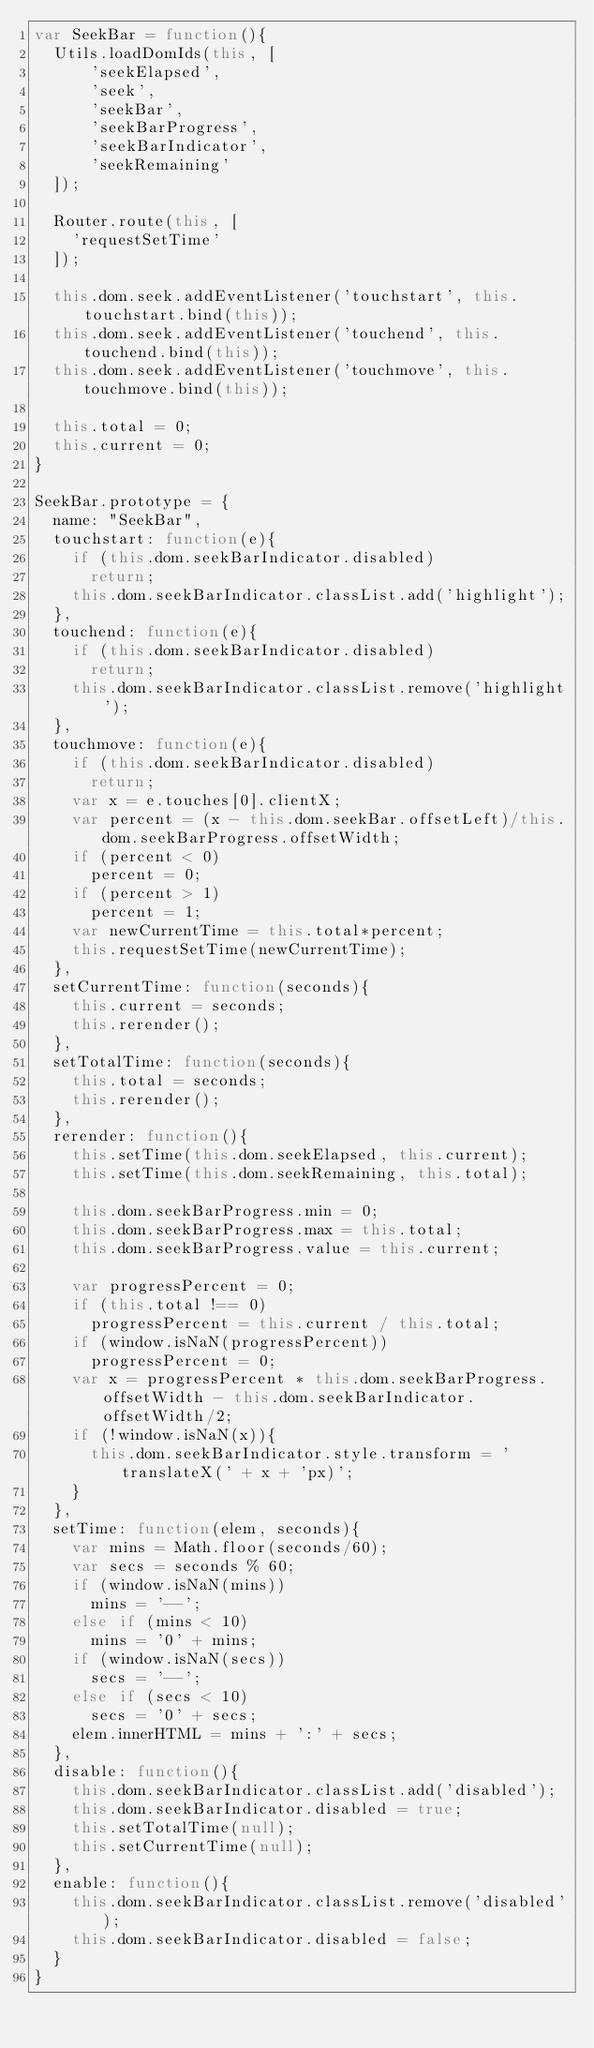<code> <loc_0><loc_0><loc_500><loc_500><_JavaScript_>var SeekBar = function(){
  Utils.loadDomIds(this, [
      'seekElapsed',
      'seek',
      'seekBar',
      'seekBarProgress',
      'seekBarIndicator',
      'seekRemaining'
  ]);

  Router.route(this, [
    'requestSetTime'
  ]);

  this.dom.seek.addEventListener('touchstart', this.touchstart.bind(this));
  this.dom.seek.addEventListener('touchend', this.touchend.bind(this));
  this.dom.seek.addEventListener('touchmove', this.touchmove.bind(this));

  this.total = 0;
  this.current = 0;
}

SeekBar.prototype = {
  name: "SeekBar",
  touchstart: function(e){
    if (this.dom.seekBarIndicator.disabled)
      return;
    this.dom.seekBarIndicator.classList.add('highlight');
  },
  touchend: function(e){
    if (this.dom.seekBarIndicator.disabled)
      return;
    this.dom.seekBarIndicator.classList.remove('highlight');
  },
  touchmove: function(e){
    if (this.dom.seekBarIndicator.disabled)
      return;
    var x = e.touches[0].clientX;
    var percent = (x - this.dom.seekBar.offsetLeft)/this.dom.seekBarProgress.offsetWidth;
    if (percent < 0)
      percent = 0;
    if (percent > 1)
      percent = 1;
    var newCurrentTime = this.total*percent;
    this.requestSetTime(newCurrentTime);
  },
  setCurrentTime: function(seconds){
    this.current = seconds;
    this.rerender();
  },
  setTotalTime: function(seconds){
    this.total = seconds;
    this.rerender();
  },
  rerender: function(){
    this.setTime(this.dom.seekElapsed, this.current);
    this.setTime(this.dom.seekRemaining, this.total);

    this.dom.seekBarProgress.min = 0;
    this.dom.seekBarProgress.max = this.total;
    this.dom.seekBarProgress.value = this.current;

    var progressPercent = 0;
    if (this.total !== 0)
      progressPercent = this.current / this.total;
    if (window.isNaN(progressPercent))
      progressPercent = 0;
    var x = progressPercent * this.dom.seekBarProgress.offsetWidth - this.dom.seekBarIndicator.offsetWidth/2;
    if (!window.isNaN(x)){
      this.dom.seekBarIndicator.style.transform = 'translateX(' + x + 'px)';
    }
  },
  setTime: function(elem, seconds){
    var mins = Math.floor(seconds/60);
    var secs = seconds % 60;
    if (window.isNaN(mins))
      mins = '--';
    else if (mins < 10)
      mins = '0' + mins;
    if (window.isNaN(secs))
      secs = '--';
    else if (secs < 10)
      secs = '0' + secs;
    elem.innerHTML = mins + ':' + secs;
  },
  disable: function(){
    this.dom.seekBarIndicator.classList.add('disabled');
    this.dom.seekBarIndicator.disabled = true;
    this.setTotalTime(null);
    this.setCurrentTime(null);
  },
  enable: function(){
    this.dom.seekBarIndicator.classList.remove('disabled');
    this.dom.seekBarIndicator.disabled = false;
  }
}
</code> 